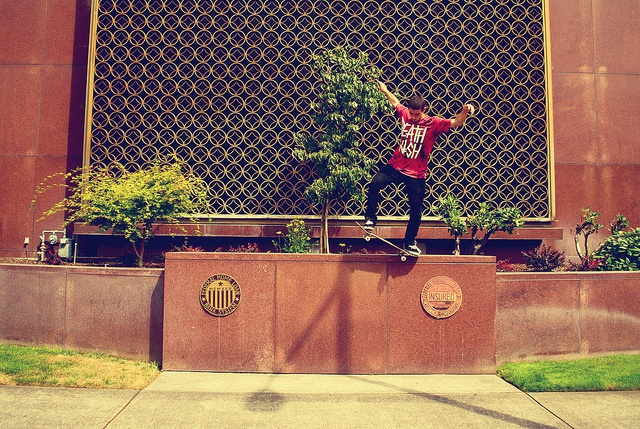Describe the objects in this image and their specific colors. I can see people in brown, navy, and purple tones and skateboard in brown, navy, and khaki tones in this image. 